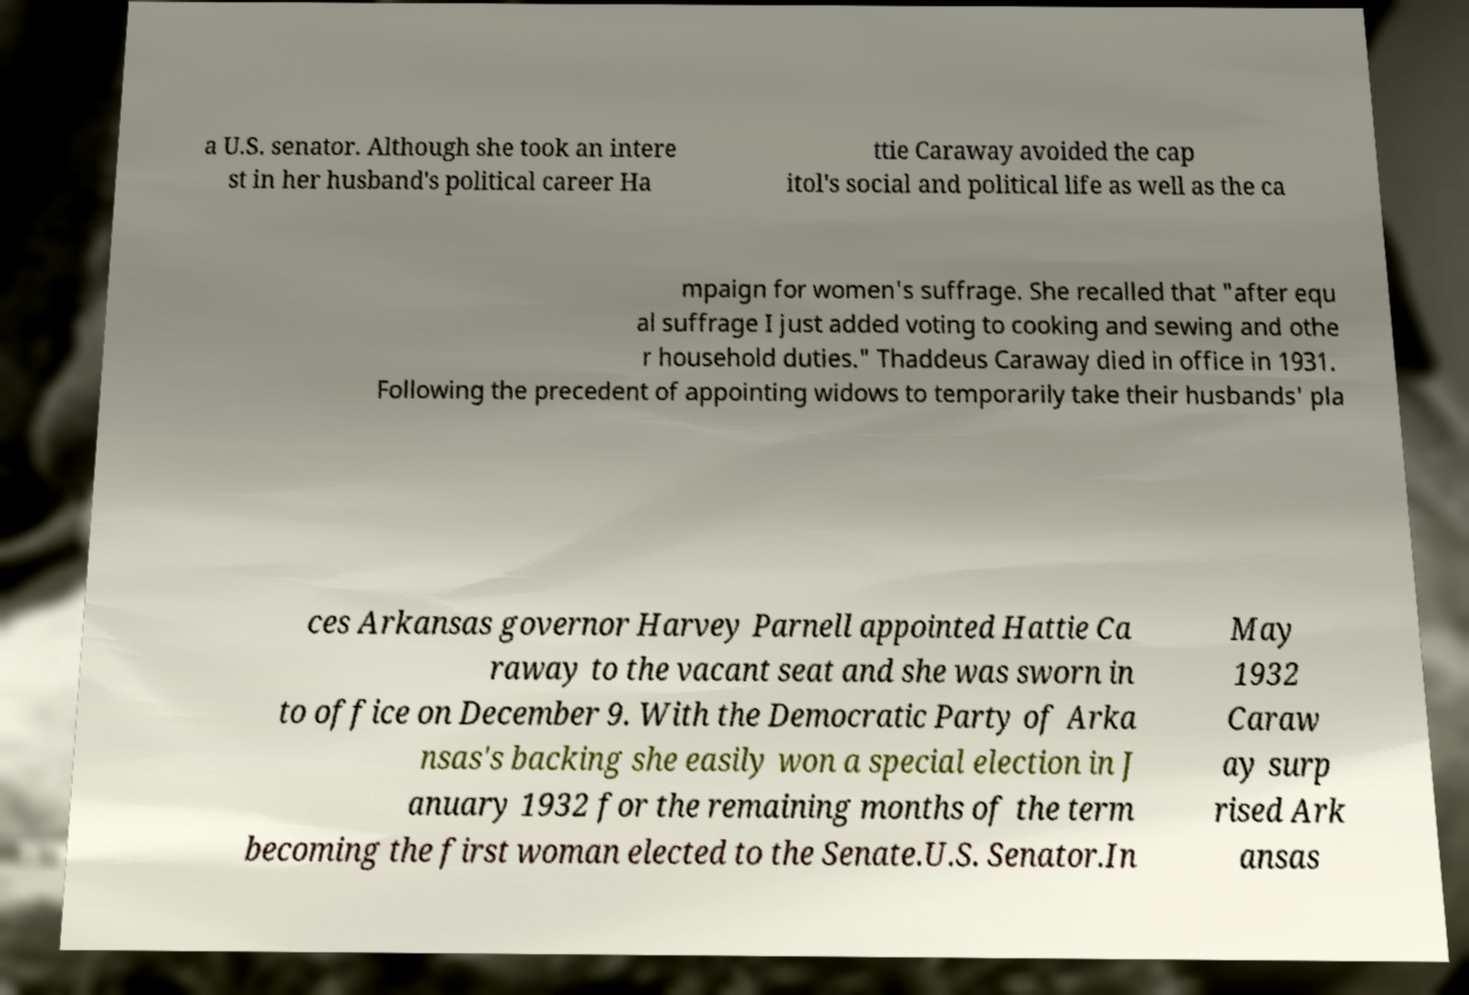There's text embedded in this image that I need extracted. Can you transcribe it verbatim? a U.S. senator. Although she took an intere st in her husband's political career Ha ttie Caraway avoided the cap itol's social and political life as well as the ca mpaign for women's suffrage. She recalled that "after equ al suffrage I just added voting to cooking and sewing and othe r household duties." Thaddeus Caraway died in office in 1931. Following the precedent of appointing widows to temporarily take their husbands' pla ces Arkansas governor Harvey Parnell appointed Hattie Ca raway to the vacant seat and she was sworn in to office on December 9. With the Democratic Party of Arka nsas's backing she easily won a special election in J anuary 1932 for the remaining months of the term becoming the first woman elected to the Senate.U.S. Senator.In May 1932 Caraw ay surp rised Ark ansas 